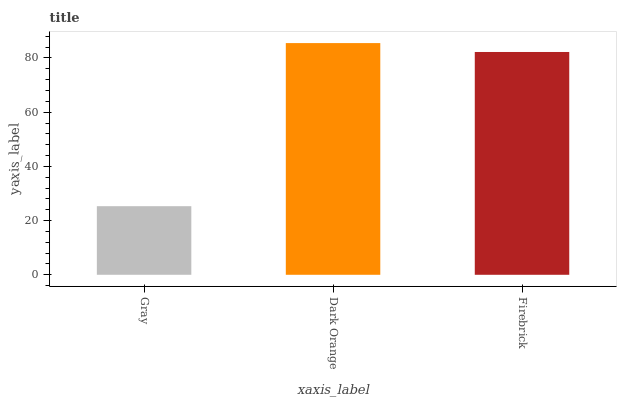Is Firebrick the minimum?
Answer yes or no. No. Is Firebrick the maximum?
Answer yes or no. No. Is Dark Orange greater than Firebrick?
Answer yes or no. Yes. Is Firebrick less than Dark Orange?
Answer yes or no. Yes. Is Firebrick greater than Dark Orange?
Answer yes or no. No. Is Dark Orange less than Firebrick?
Answer yes or no. No. Is Firebrick the high median?
Answer yes or no. Yes. Is Firebrick the low median?
Answer yes or no. Yes. Is Gray the high median?
Answer yes or no. No. Is Gray the low median?
Answer yes or no. No. 